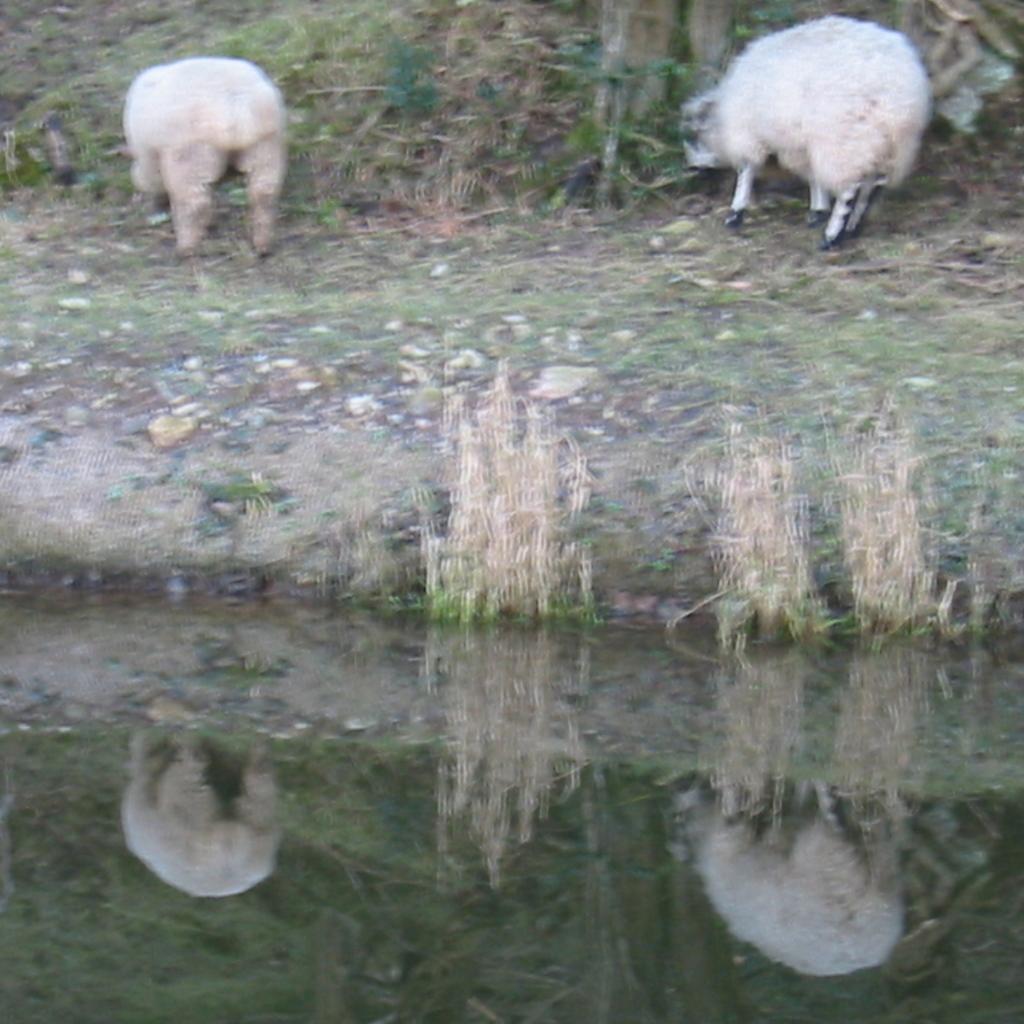Describe this image in one or two sentences. In this image in the foreground there is water body. In the background there is plants. Two sheep are grazing here. 